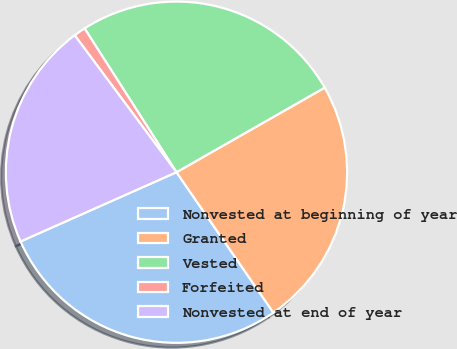Convert chart to OTSL. <chart><loc_0><loc_0><loc_500><loc_500><pie_chart><fcel>Nonvested at beginning of year<fcel>Granted<fcel>Vested<fcel>Forfeited<fcel>Nonvested at end of year<nl><fcel>27.96%<fcel>23.64%<fcel>25.8%<fcel>1.12%<fcel>21.48%<nl></chart> 